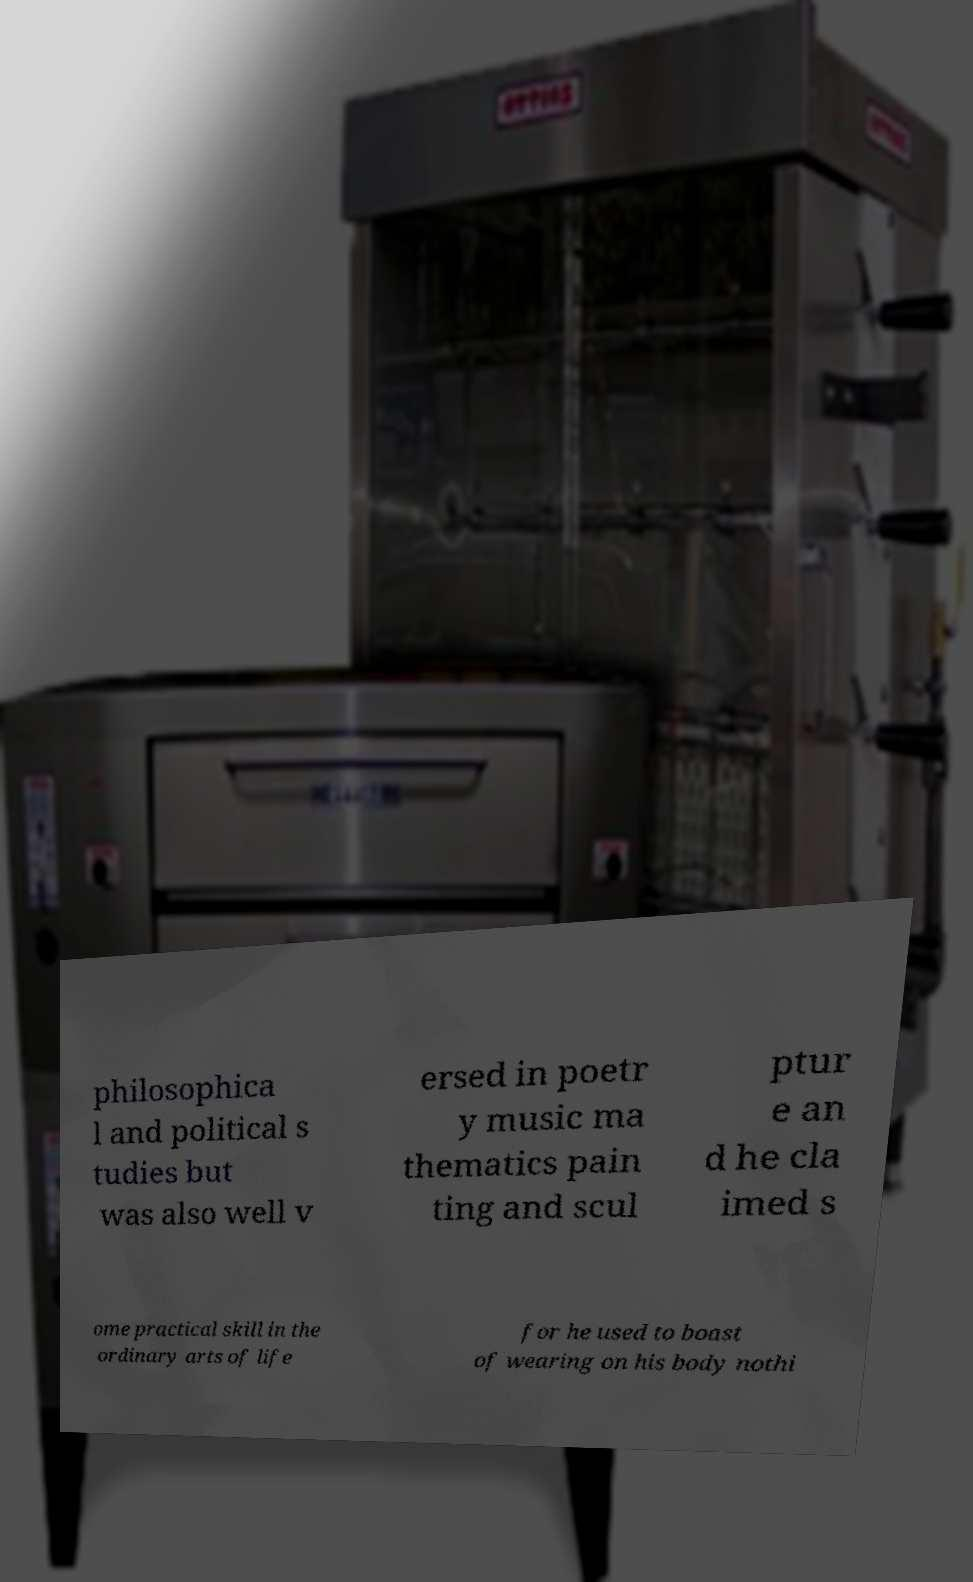Could you extract and type out the text from this image? philosophica l and political s tudies but was also well v ersed in poetr y music ma thematics pain ting and scul ptur e an d he cla imed s ome practical skill in the ordinary arts of life for he used to boast of wearing on his body nothi 